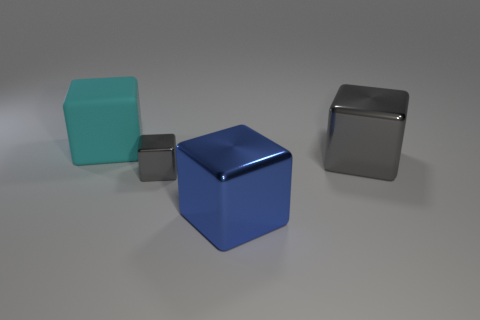Subtract all big blue metallic cubes. How many cubes are left? 3 Subtract all cyan blocks. How many blocks are left? 3 Subtract all red blocks. Subtract all cyan cylinders. How many blocks are left? 4 Add 1 large matte blocks. How many objects exist? 5 Add 1 big shiny cubes. How many big shiny cubes exist? 3 Subtract 0 brown balls. How many objects are left? 4 Subtract all yellow metal cubes. Subtract all big metallic blocks. How many objects are left? 2 Add 4 tiny metal blocks. How many tiny metal blocks are left? 5 